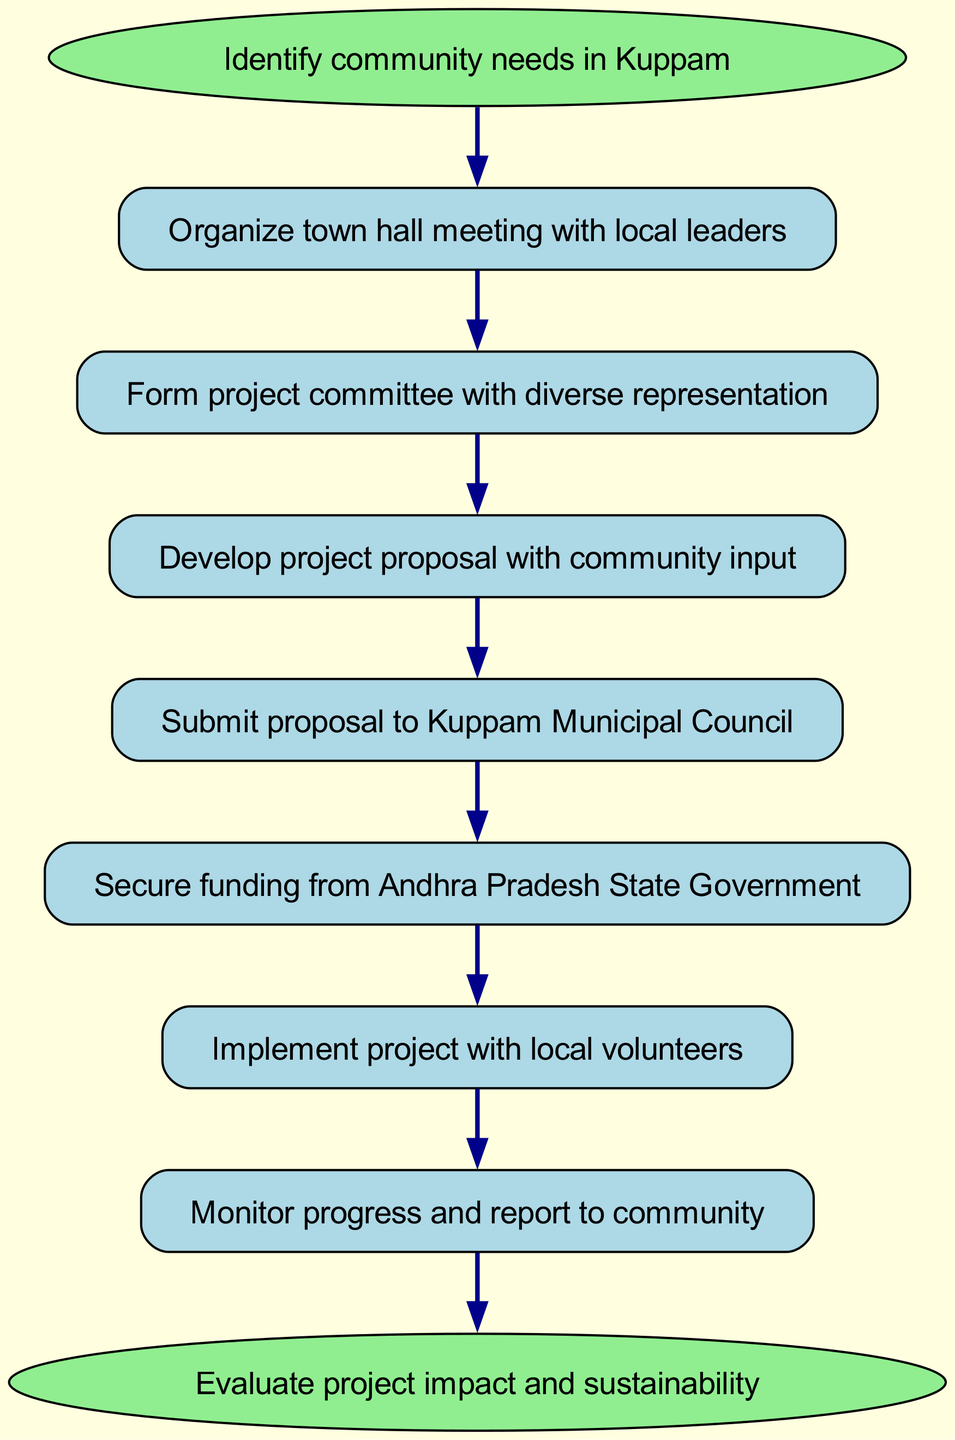What is the first step in the community-driven development project? The first step, as indicated by the starting node, is to identify community needs in Kuppam. This is illustrated at the top of the flowchart leading to the subsequent steps.
Answer: Identify community needs in Kuppam How many steps are there in the development project? To find the number of steps, we count the nodes except for the start and end nodes. The steps between them are organized sequentially, totaling seven distinct actions.
Answer: Seven What is the last action before project evaluation? The last action before evaluation, according to the flowchart, is to monitor progress and report to the community. This is the final step leading directly into evaluation.
Answer: Monitor progress and report to community Which step involves securing funding? The step that involves securing funding is clearly marked in the diagram as "Secure funding from Andhra Pradesh State Government." It follows the submission of the proposal.
Answer: Secure funding from Andhra Pradesh State Government What comes after developing the project proposal? After developing the project proposal with community input, the next step is to submit the proposal to Kuppam Municipal Council, as depicted in the flowchart.
Answer: Submit proposal to Kuppam Municipal Council How many edges are there in the diagram? The edges represent the connections between the steps in the diagram. By counting all the directed connections, we find there are eight edges illustrating the flow from one step to the next.
Answer: Eight What type of meeting is organized in the first step? The first step describes organizing a town hall meeting with local leaders, which is essential for gathering input and discussing community needs.
Answer: Town hall meeting What is the purpose of forming a project committee? Forming a project committee with diverse representation is aimed at ensuring that the development project considers various perspectives and needs within the community. This is a key step to engage different community stakeholders.
Answer: To ensure diverse representation What is the overall goal of the flowchart? The overall goal of the flowchart is to initiate and implement a community-driven development project in Kuppam successfully, culminating in evaluating project impact and sustainability.
Answer: To initiate and implement a community-driven development project in Kuppam 